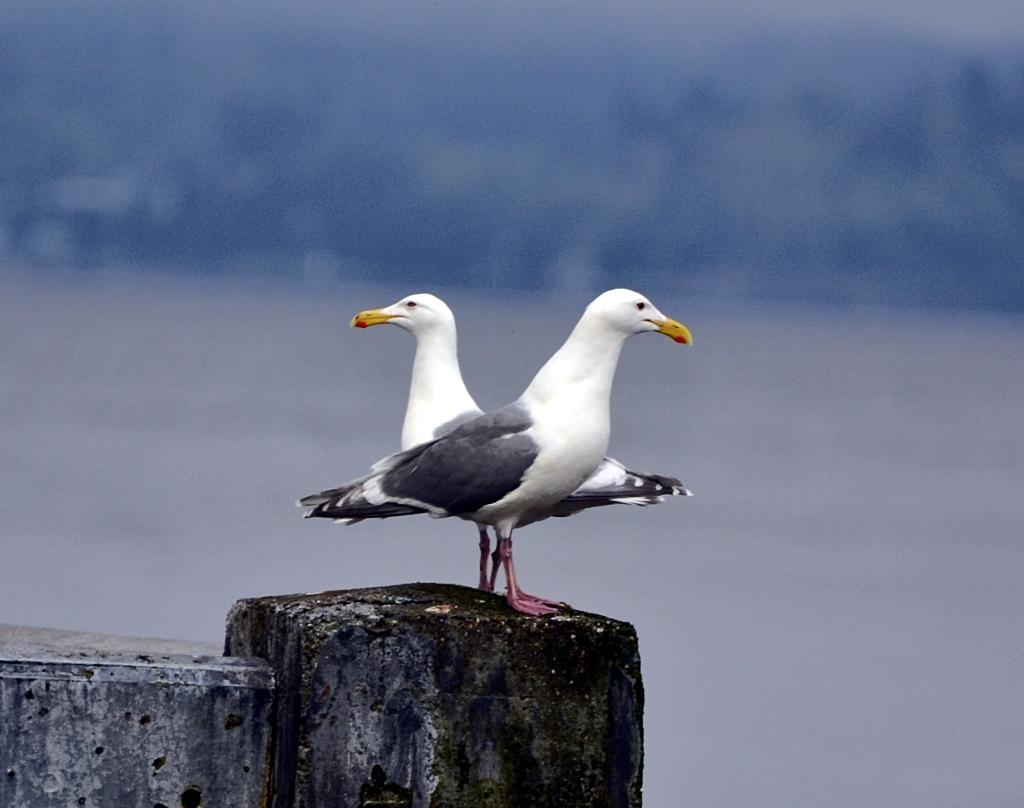How many birds are present in the image? There are two birds in the image. Where are the birds located? The birds are on a wall. What color are the bird's wings? The bird's wings are in black color. Can you describe the background of the image? The background of the image is blurred. Is there a store nearby where the writer can buy a new pen? There is no store or writer mentioned in the image, so it's not possible to answer that question. 